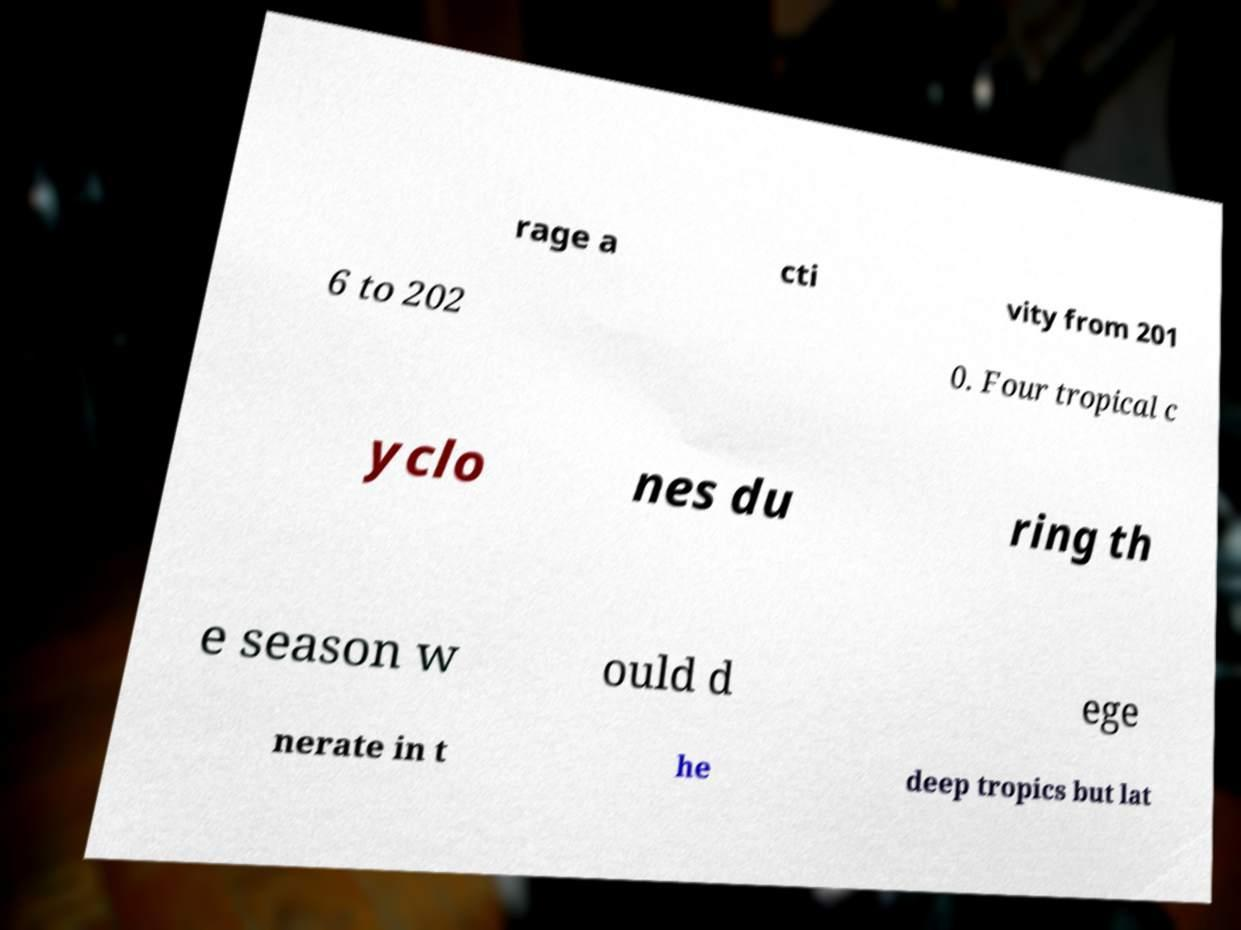For documentation purposes, I need the text within this image transcribed. Could you provide that? rage a cti vity from 201 6 to 202 0. Four tropical c yclo nes du ring th e season w ould d ege nerate in t he deep tropics but lat 